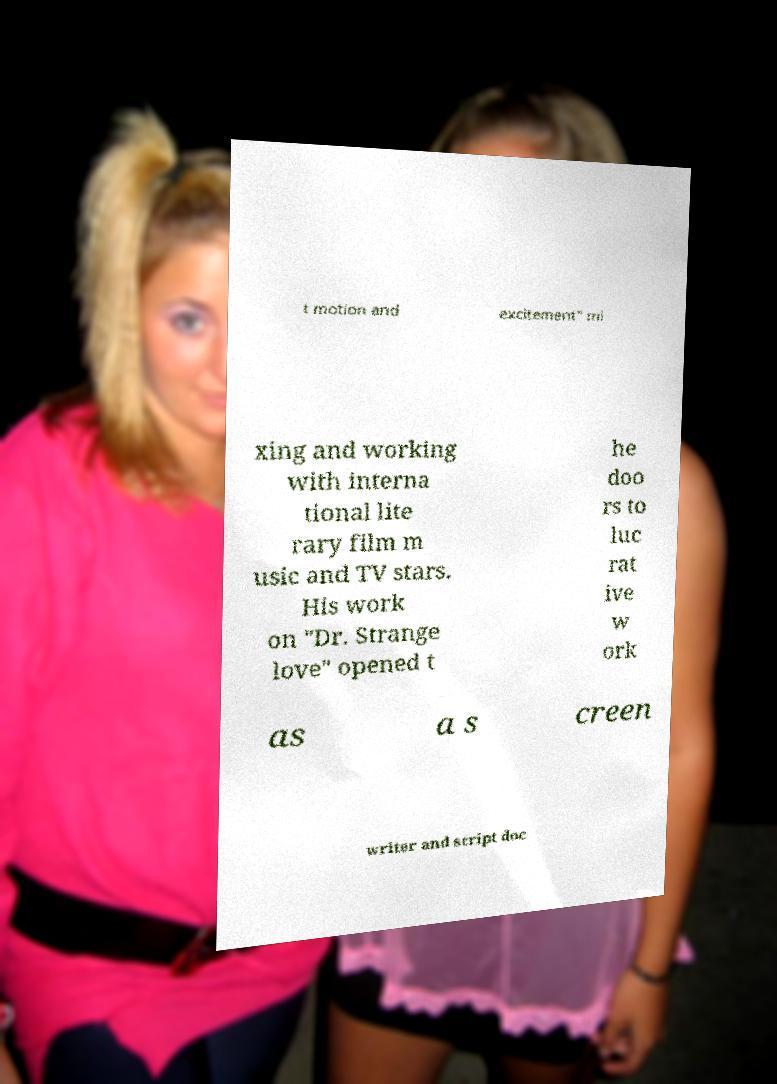Please identify and transcribe the text found in this image. t motion and excitement" mi xing and working with interna tional lite rary film m usic and TV stars. His work on "Dr. Strange love" opened t he doo rs to luc rat ive w ork as a s creen writer and script doc 